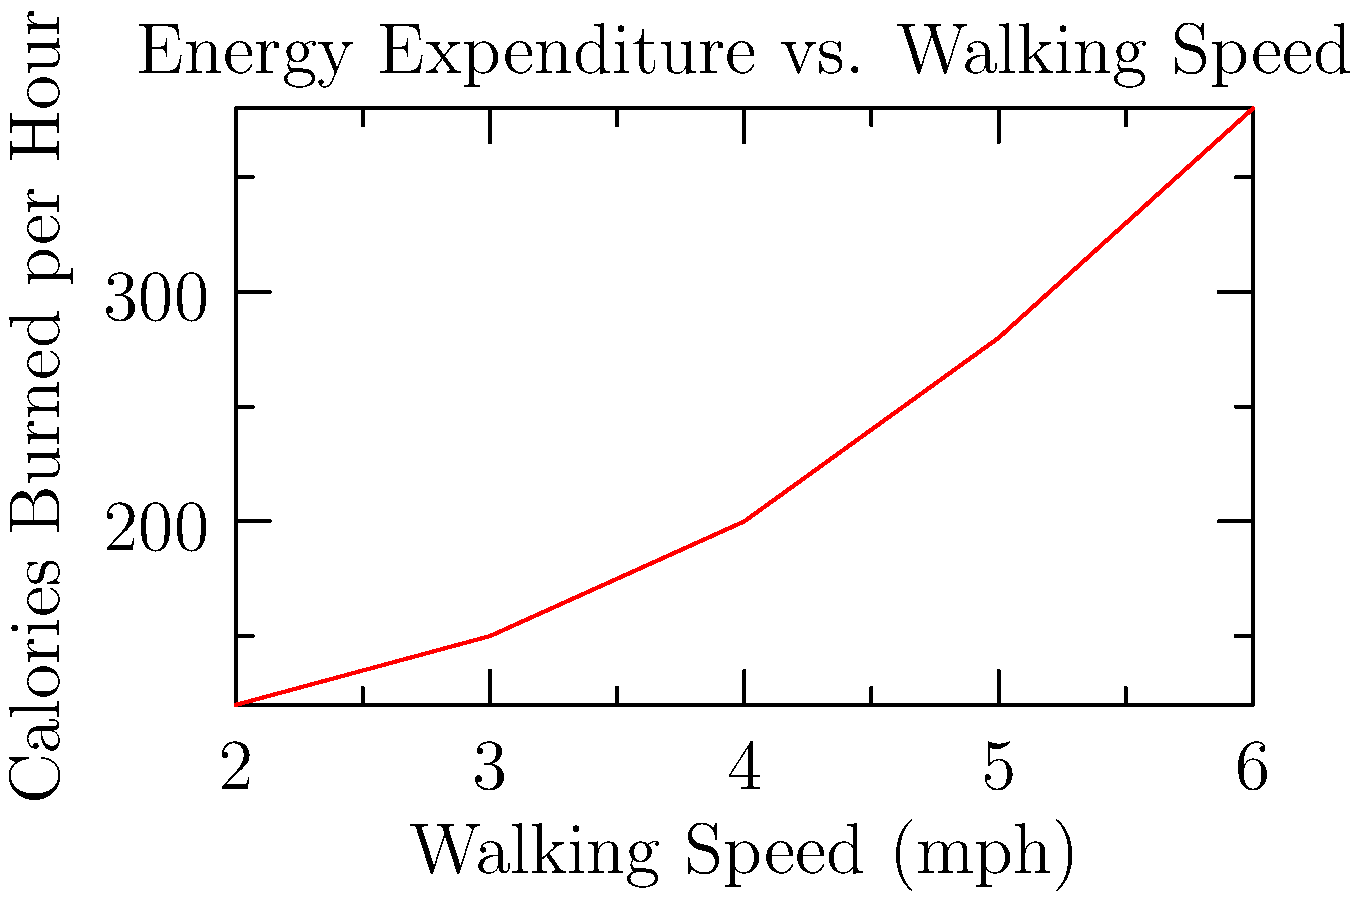Based on the graph showing the relationship between walking speed and calories burned per hour, which walking speed would be most efficient for burning calories while minimizing joint stress during a 30-minute daily exercise routine? To answer this question, we need to consider both calorie burn and joint stress:

1. Analyze the graph:
   - As walking speed increases, calories burned per hour increases.
   - The relationship is non-linear, with a steeper increase at higher speeds.

2. Consider joint stress:
   - Higher speeds generally lead to more joint stress.
   - We want to find a balance between calorie burn and minimizing joint stress.

3. Evaluate the options:
   - 2 mph: Low calorie burn (about 120 cal/hour)
   - 3 mph: Moderate calorie burn (about 150 cal/hour)
   - 4 mph: Good calorie burn (about 200 cal/hour)
   - 5 mph: High calorie burn (about 280 cal/hour)
   - 6 mph: Highest calorie burn (about 380 cal/hour), but likely too intense for daily exercise

4. Choose the optimal speed:
   - 4 mph provides a good balance of calorie burn and manageable joint stress.
   - It's a brisk walk, which is sustainable for daily exercise.
   - At 4 mph, you'd burn approximately 100 calories in a 30-minute session.

5. Consider the persona:
   - As a young adult transitioning to independent living, a sustainable and efficient exercise routine is important.
   - 4 mph is challenging enough to provide health benefits without being too strenuous.
Answer: 4 mph 